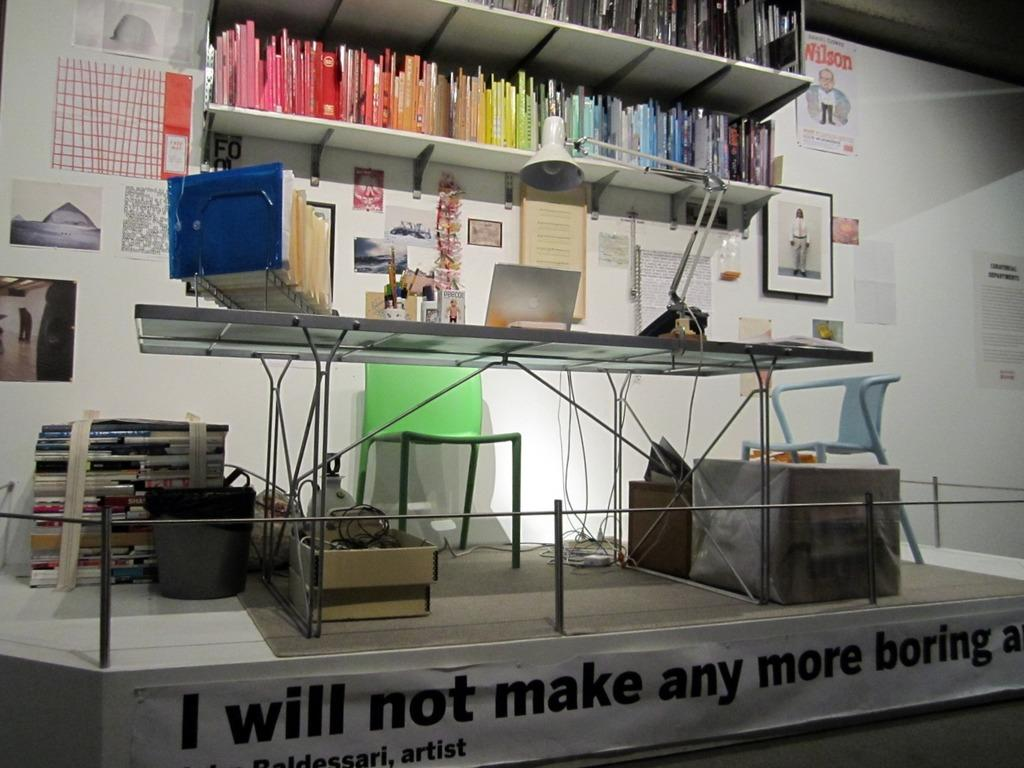Provide a one-sentence caption for the provided image. The banner attached to the work space states "I will not make any more boring art". 